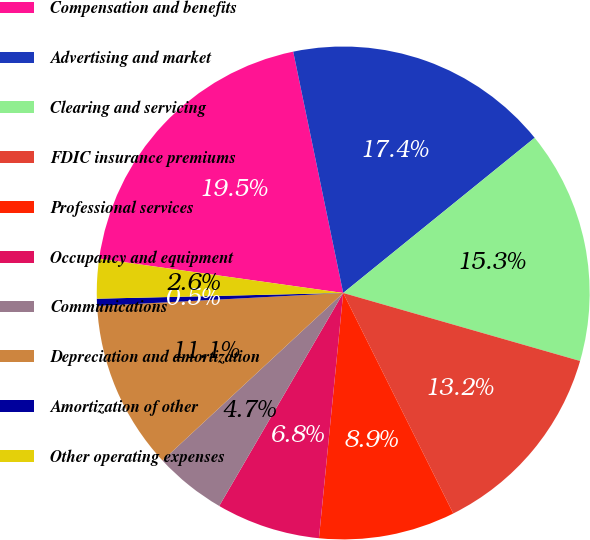Convert chart. <chart><loc_0><loc_0><loc_500><loc_500><pie_chart><fcel>Compensation and benefits<fcel>Advertising and market<fcel>Clearing and servicing<fcel>FDIC insurance premiums<fcel>Professional services<fcel>Occupancy and equipment<fcel>Communications<fcel>Depreciation and amortization<fcel>Amortization of other<fcel>Other operating expenses<nl><fcel>19.53%<fcel>17.41%<fcel>15.29%<fcel>13.18%<fcel>8.94%<fcel>6.82%<fcel>4.71%<fcel>11.06%<fcel>0.47%<fcel>2.59%<nl></chart> 